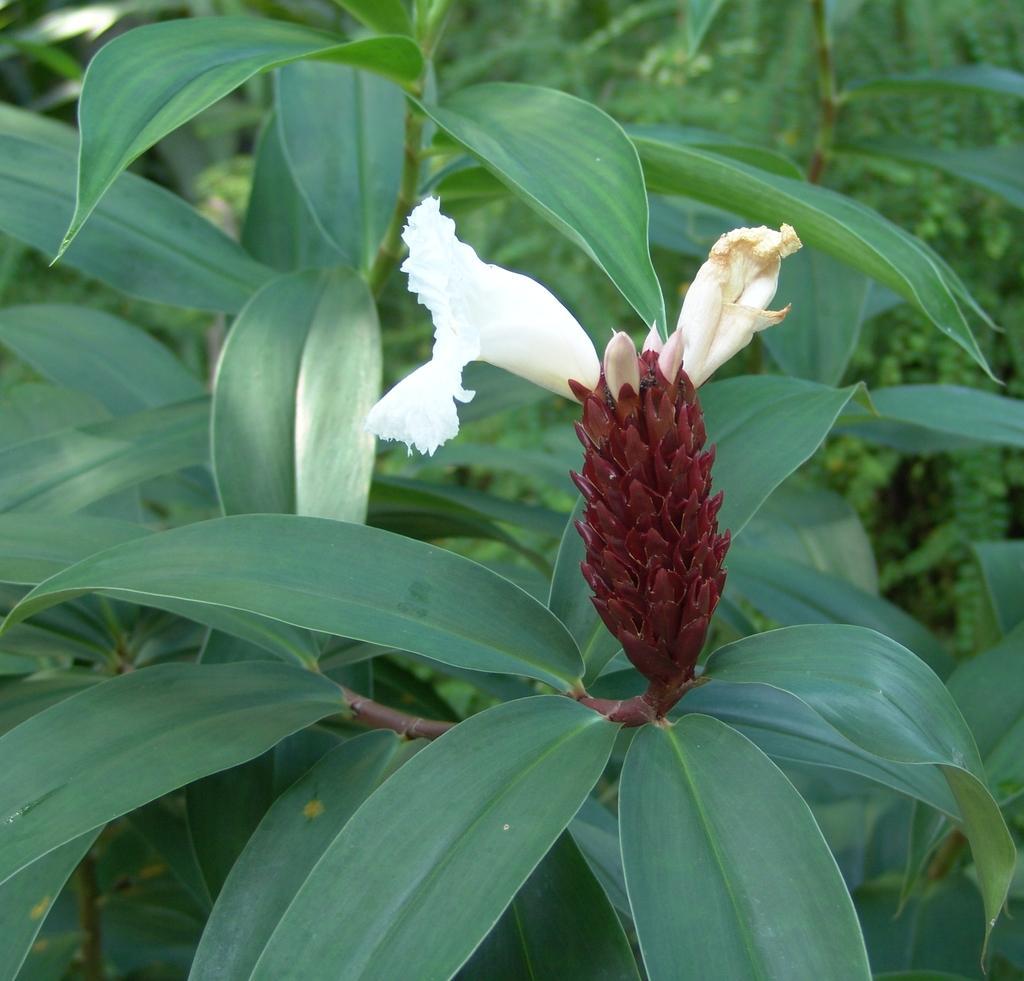Describe this image in one or two sentences. In this picture we can see a flower, leaves and in the background we can see trees. 